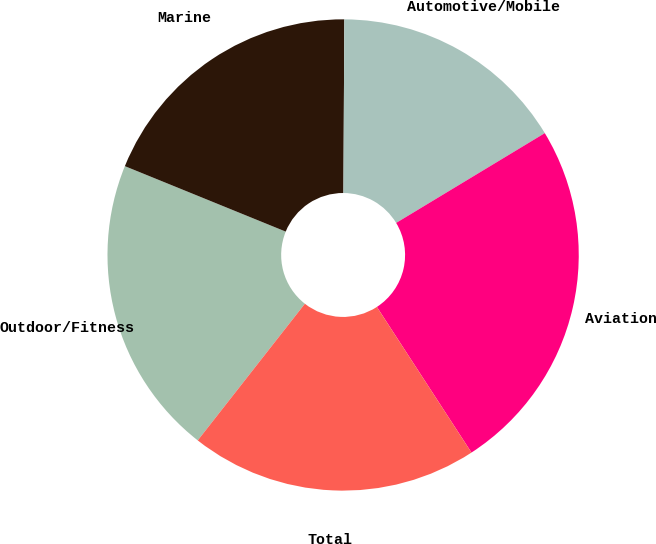<chart> <loc_0><loc_0><loc_500><loc_500><pie_chart><fcel>Outdoor/Fitness<fcel>Marine<fcel>Automotive/Mobile<fcel>Aviation<fcel>Total<nl><fcel>20.57%<fcel>18.93%<fcel>16.27%<fcel>24.48%<fcel>19.75%<nl></chart> 